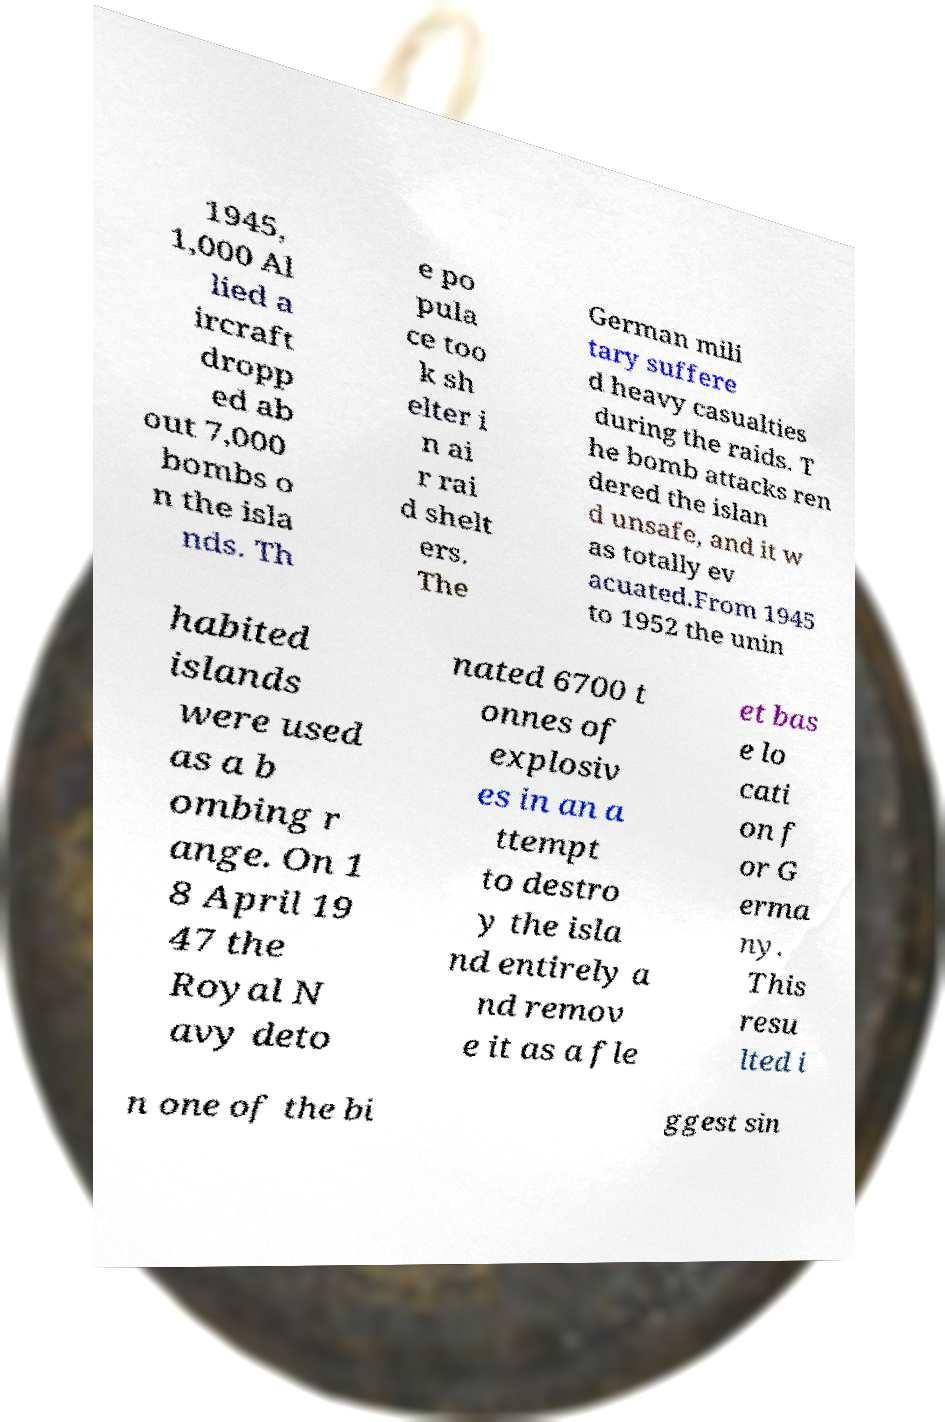I need the written content from this picture converted into text. Can you do that? 1945, 1,000 Al lied a ircraft dropp ed ab out 7,000 bombs o n the isla nds. Th e po pula ce too k sh elter i n ai r rai d shelt ers. The German mili tary suffere d heavy casualties during the raids. T he bomb attacks ren dered the islan d unsafe, and it w as totally ev acuated.From 1945 to 1952 the unin habited islands were used as a b ombing r ange. On 1 8 April 19 47 the Royal N avy deto nated 6700 t onnes of explosiv es in an a ttempt to destro y the isla nd entirely a nd remov e it as a fle et bas e lo cati on f or G erma ny. This resu lted i n one of the bi ggest sin 